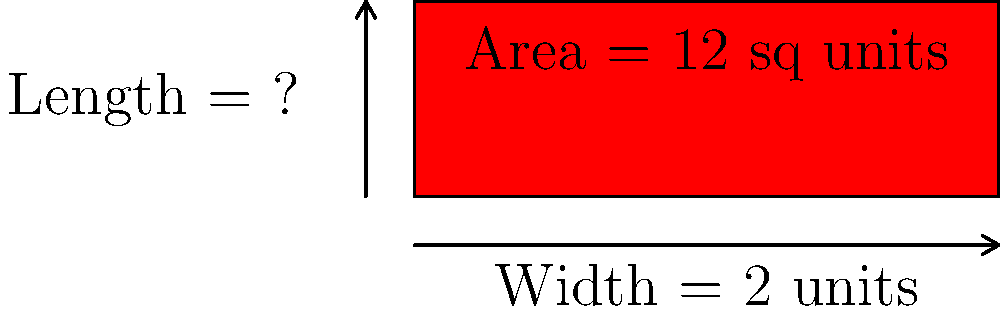Imagine you're preparing for a big audition, and you need to walk down a rectangular red carpet. The carpet's area is 12 square units, and its width is 2 units. Can you calculate the length of the carpet, just like Mason Vale Cotton might do for a movie scene? Let's solve this step-by-step, like we're breaking down a script:

1) We know that the area of a rectangle is given by the formula:
   $$ \text{Area} = \text{Length} \times \text{Width} $$

2) We're given that:
   - Area = 12 square units
   - Width = 2 units

3) Let's call the length $L$. We can substitute these values into our formula:
   $$ 12 = L \times 2 $$

4) Now, we can solve for $L$ by dividing both sides by 2:
   $$ L = 12 \div 2 $$

5) Simplifying:
   $$ L = 6 $$

So, just like Mason Vale Cotton would memorize his lines, remember that the length of the red carpet is 6 units!
Answer: 6 units 